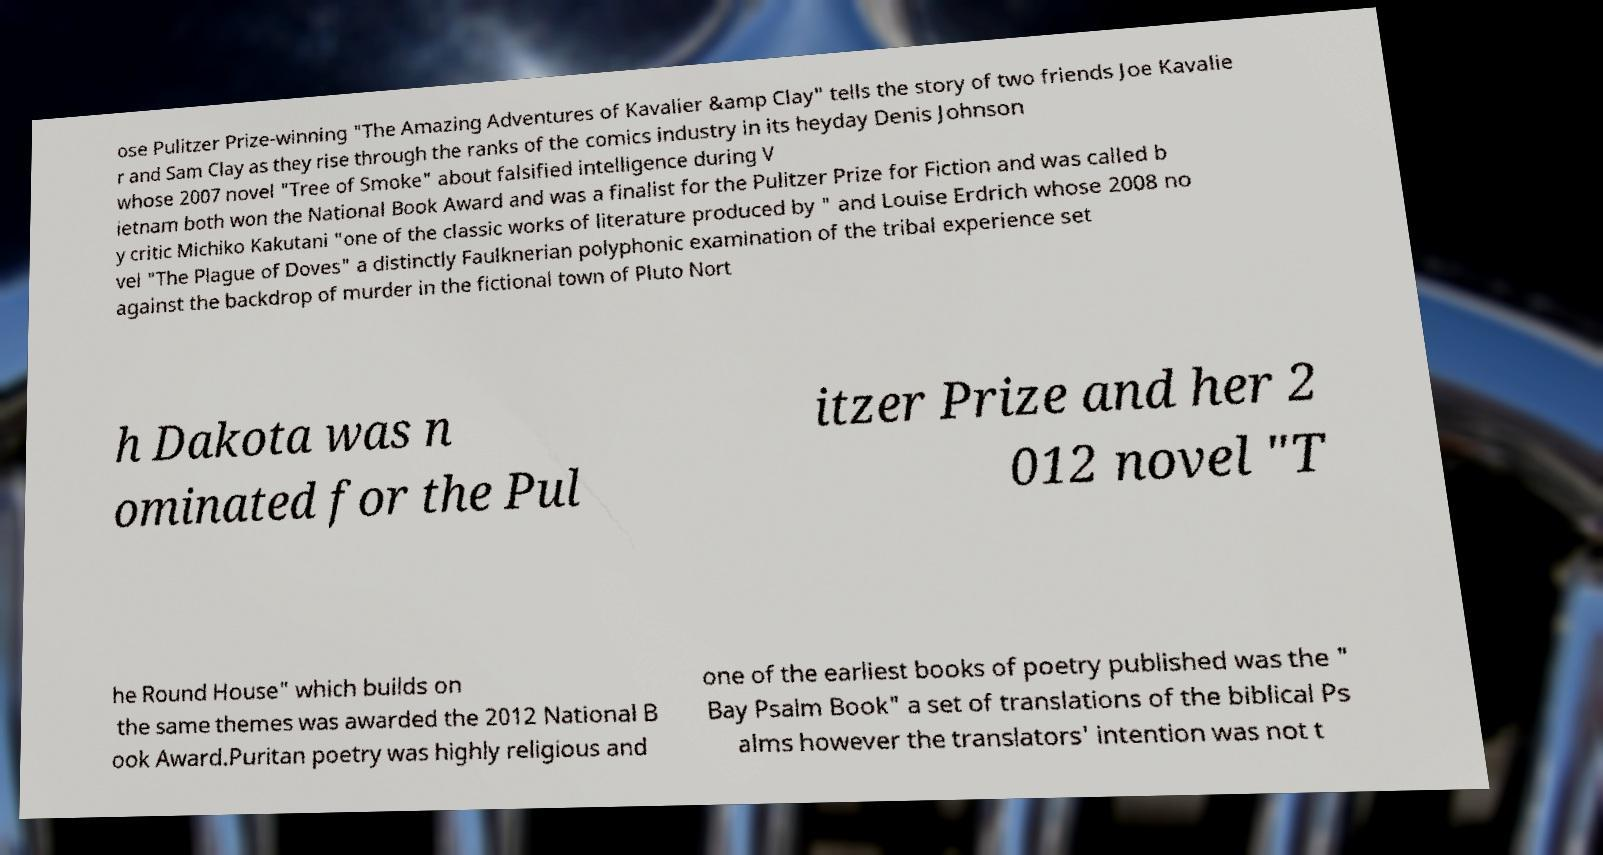Please read and relay the text visible in this image. What does it say? ose Pulitzer Prize-winning "The Amazing Adventures of Kavalier &amp Clay" tells the story of two friends Joe Kavalie r and Sam Clay as they rise through the ranks of the comics industry in its heyday Denis Johnson whose 2007 novel "Tree of Smoke" about falsified intelligence during V ietnam both won the National Book Award and was a finalist for the Pulitzer Prize for Fiction and was called b y critic Michiko Kakutani "one of the classic works of literature produced by " and Louise Erdrich whose 2008 no vel "The Plague of Doves" a distinctly Faulknerian polyphonic examination of the tribal experience set against the backdrop of murder in the fictional town of Pluto Nort h Dakota was n ominated for the Pul itzer Prize and her 2 012 novel "T he Round House" which builds on the same themes was awarded the 2012 National B ook Award.Puritan poetry was highly religious and one of the earliest books of poetry published was the " Bay Psalm Book" a set of translations of the biblical Ps alms however the translators' intention was not t 